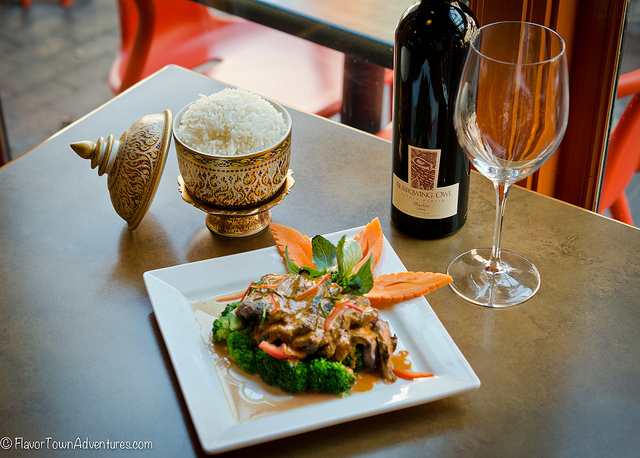Identify the text displayed in this image. FlavorTownAdventures.com 